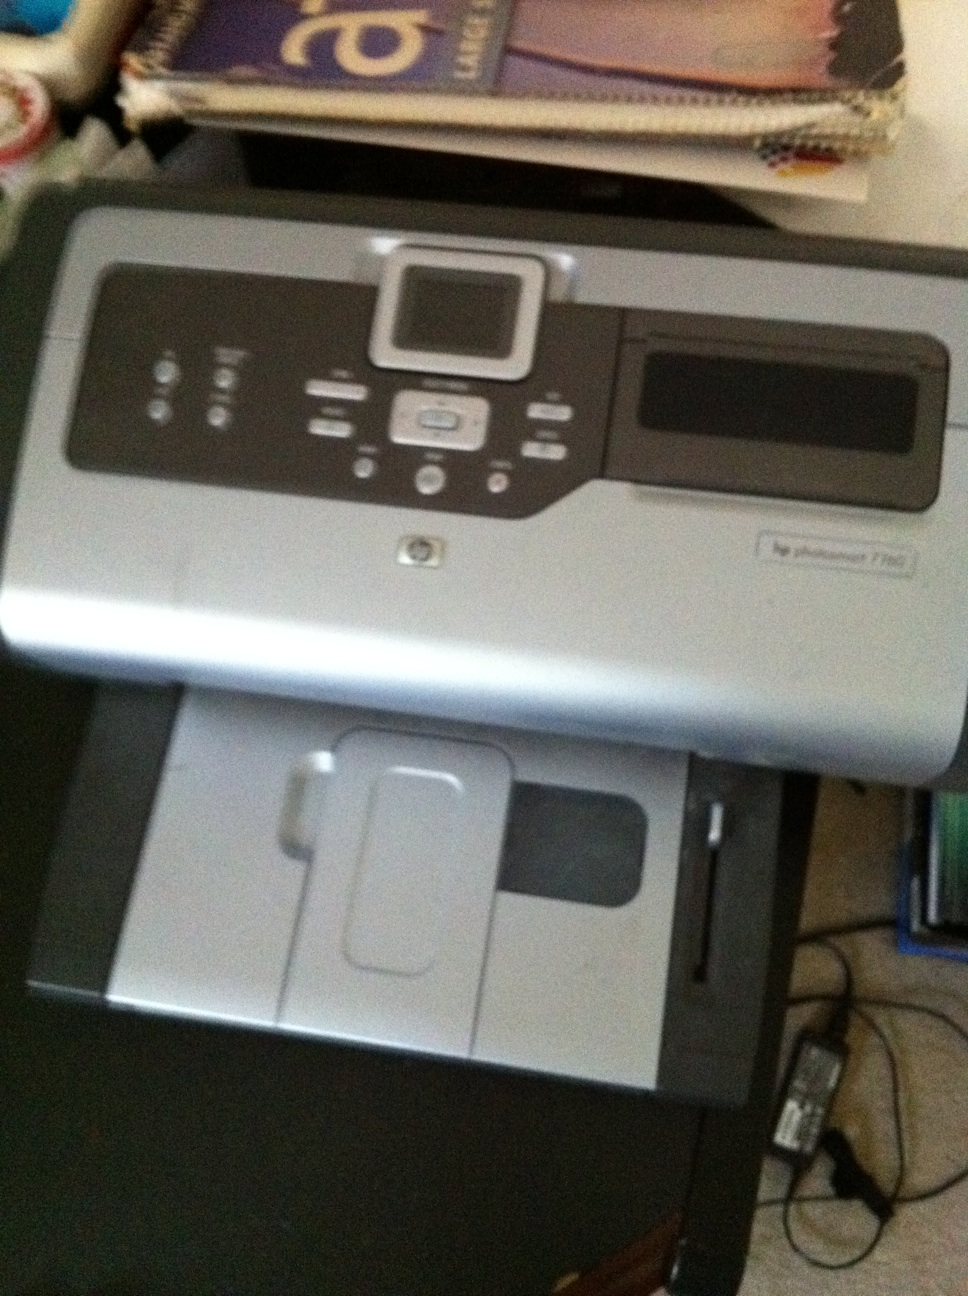Can this printer print high-quality photos? Yes, the HP Photosmart 7280 is designed to print high-quality photos. It supports up to 4800 x 1200 optimized dpi color when printing from a computer on selected HP photo papers. 